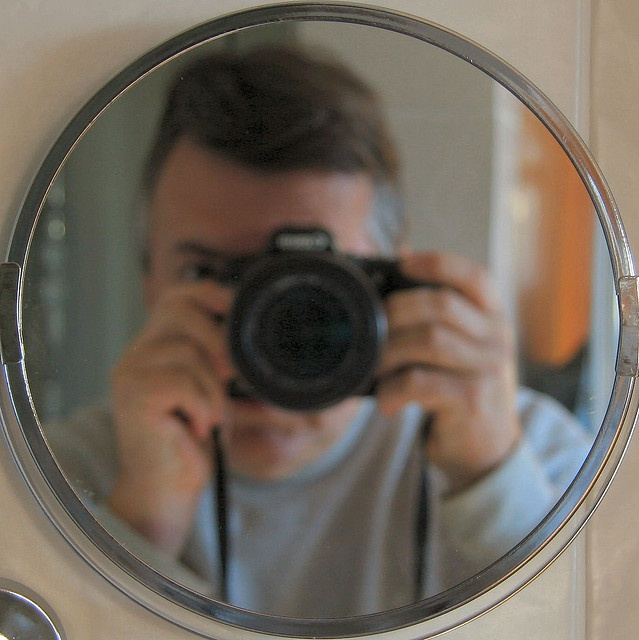Describe the objects in this image and their specific colors. I can see people in darkgray, gray, black, and maroon tones in this image. 